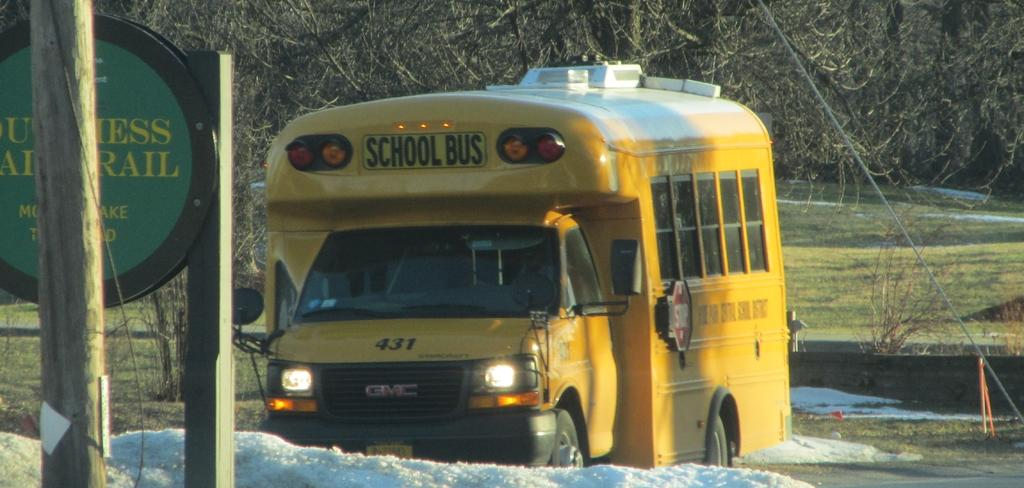What type of vehicle is in the image? There is a vehicle in the image, but the specific type is not mentioned. What color is the vehicle? The vehicle is yellow. What is attached to a wooden pole in front of the vehicle? There is a board attached to a wooden pole in front of the vehicle. What can be seen in the background of the image? There are trees visible in the background of the image. How many eyes can be seen on the vehicle in the image? There are no eyes visible on the vehicle in the image, as vehicles do not have eyes. 